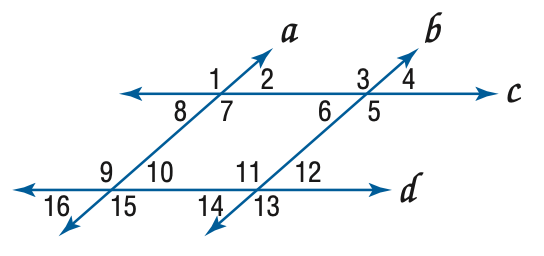Question: In the figure, a \parallel b, c \parallel d, and m \angle 4 = 57. Find the measure of \angle 1.
Choices:
A. 57
B. 113
C. 123
D. 133
Answer with the letter. Answer: C 